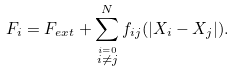<formula> <loc_0><loc_0><loc_500><loc_500>F _ { i } = F _ { e x t } + \sum _ { \stackrel { i = 0 } { i \ne j } } ^ { N } f _ { i j } ( | { X } _ { i } - { X } _ { j } | ) .</formula> 